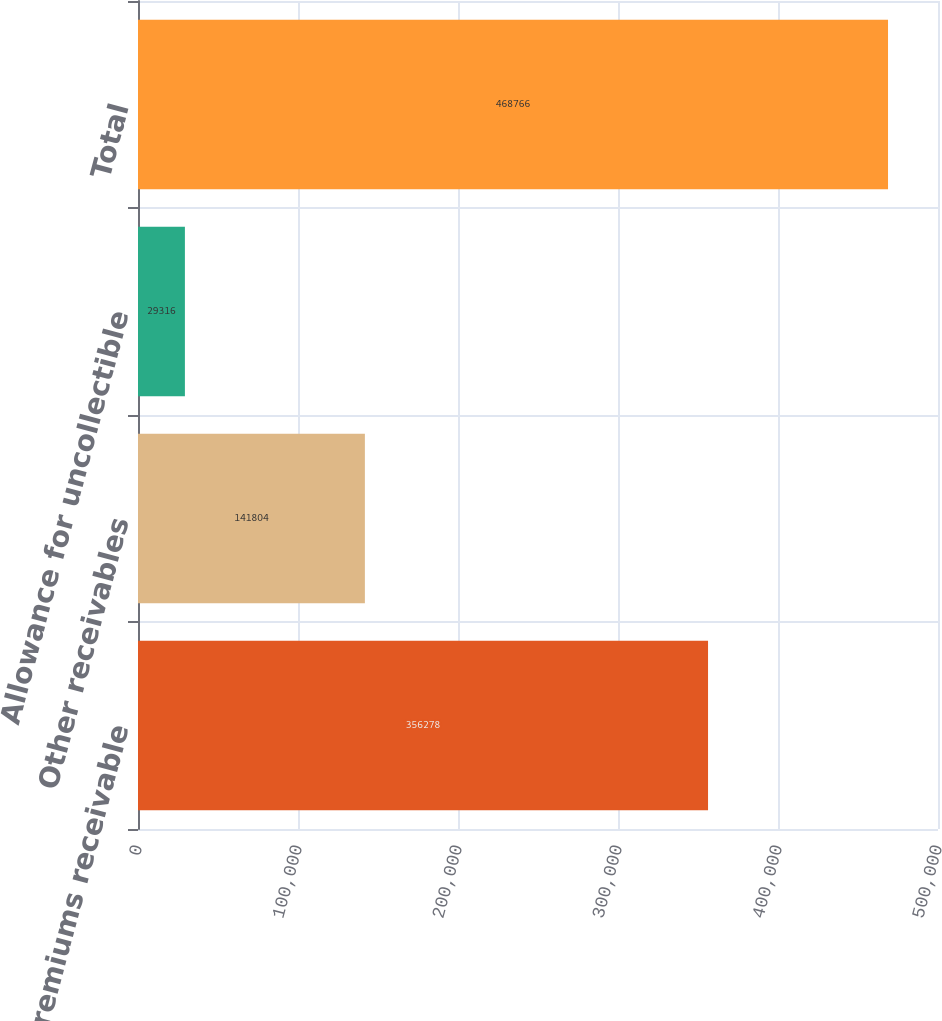<chart> <loc_0><loc_0><loc_500><loc_500><bar_chart><fcel>Insurance premiums receivable<fcel>Other receivables<fcel>Allowance for uncollectible<fcel>Total<nl><fcel>356278<fcel>141804<fcel>29316<fcel>468766<nl></chart> 